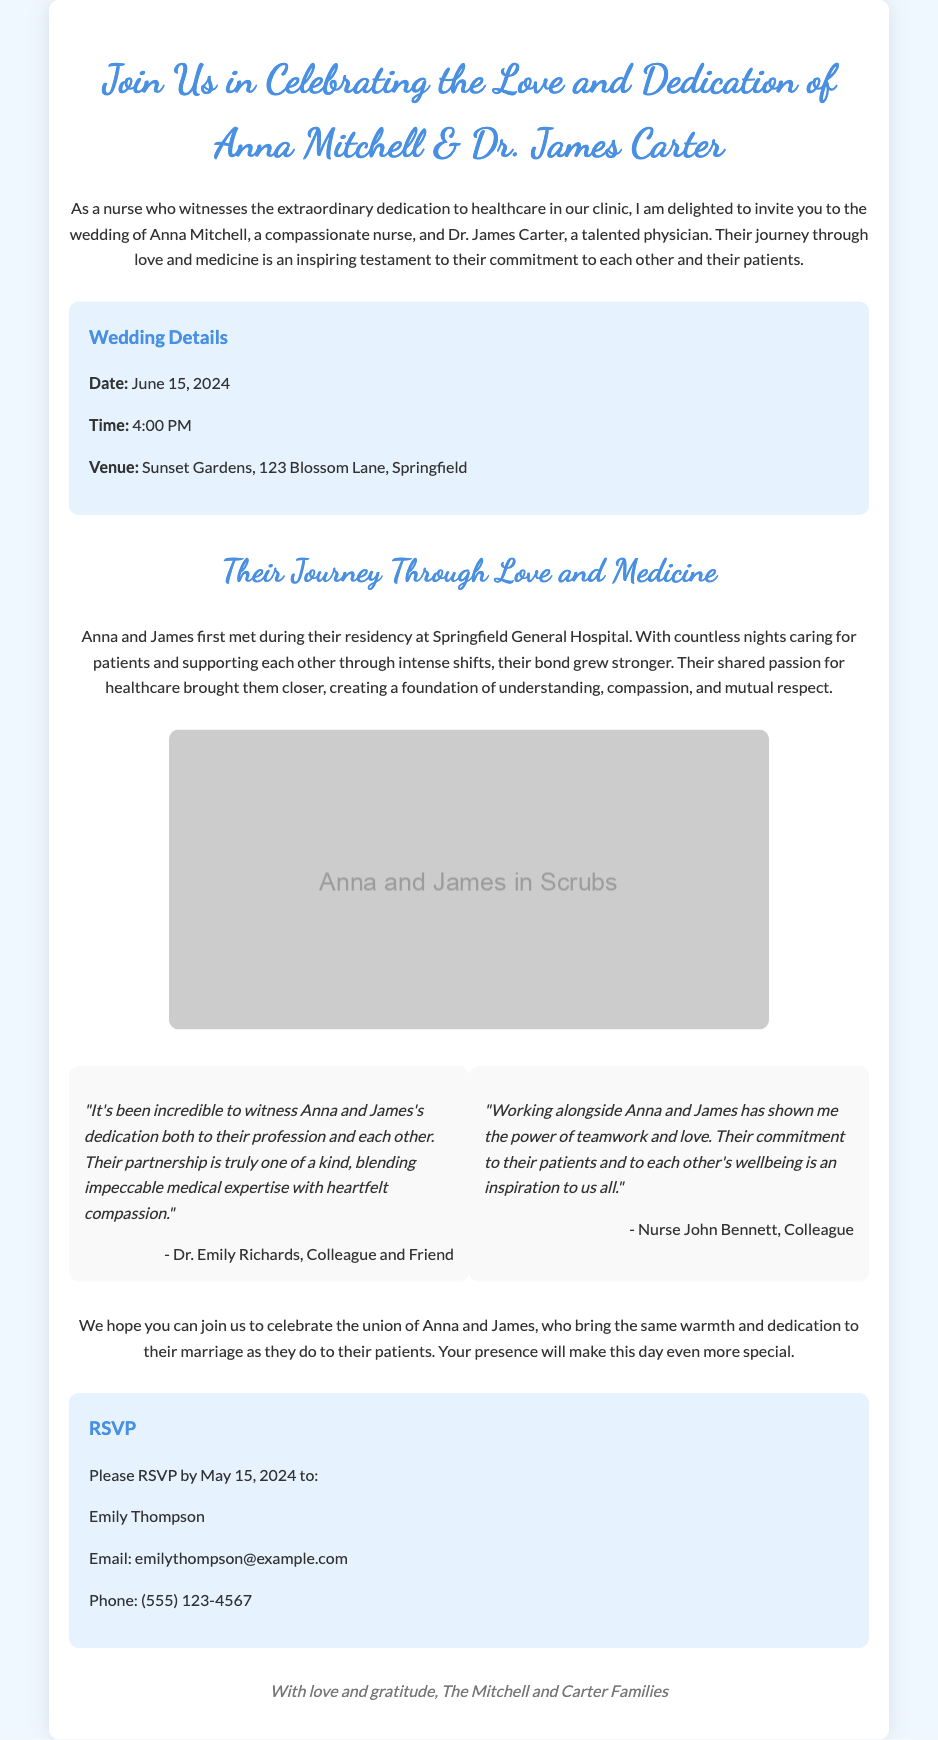What is the date of the wedding? The date of the wedding is explicitly mentioned in the details section of the invitation.
Answer: June 15, 2024 What venue will the wedding be held at? The invitation provides the venue location in the details section.
Answer: Sunset Gardens, 123 Blossom Lane, Springfield Who are the couple getting married? The invitation clearly states the names of the couple at the beginning.
Answer: Anna Mitchell & Dr. James Carter What is the RSVP deadline? The RSVP deadline is mentioned in the details section for the RSVP.
Answer: May 15, 2024 What profession does Anna Mitchell have? The document indicates Anna's profession early in the introduction.
Answer: Nurse What was a significant moment in Anna and James's relationship? The story section describes their meeting during a significant time in their careers.
Answer: Their residency Who provided a testimonial stating the partnership is one of a kind? The document attributes the first testimonial to a specific colleague.
Answer: Dr. Emily Richards, Colleague and Friend What kind of illustrations are featured in the invitation? The illustration section indicates the type of artwork used in the invitation.
Answer: Warm nurse-themed illustrations What is the significance of the couple's dedication? Their dedication intertwines love and profession, creating a unique bond described throughout the invitation.
Answer: Love and medicine 